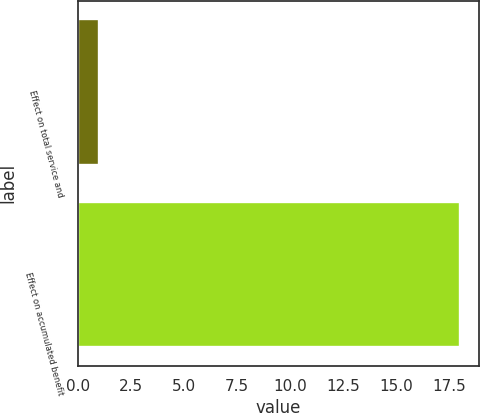Convert chart. <chart><loc_0><loc_0><loc_500><loc_500><bar_chart><fcel>Effect on total service and<fcel>Effect on accumulated benefit<nl><fcel>1<fcel>18<nl></chart> 